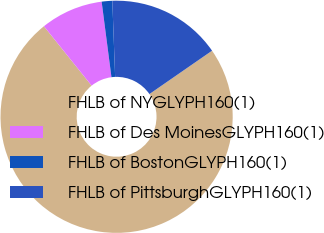Convert chart to OTSL. <chart><loc_0><loc_0><loc_500><loc_500><pie_chart><fcel>FHLB of NYGLYPH160(1)<fcel>FHLB of Des MoinesGLYPH160(1)<fcel>FHLB of BostonGLYPH160(1)<fcel>FHLB of PittsburghGLYPH160(1)<nl><fcel>73.87%<fcel>8.71%<fcel>1.47%<fcel>15.95%<nl></chart> 